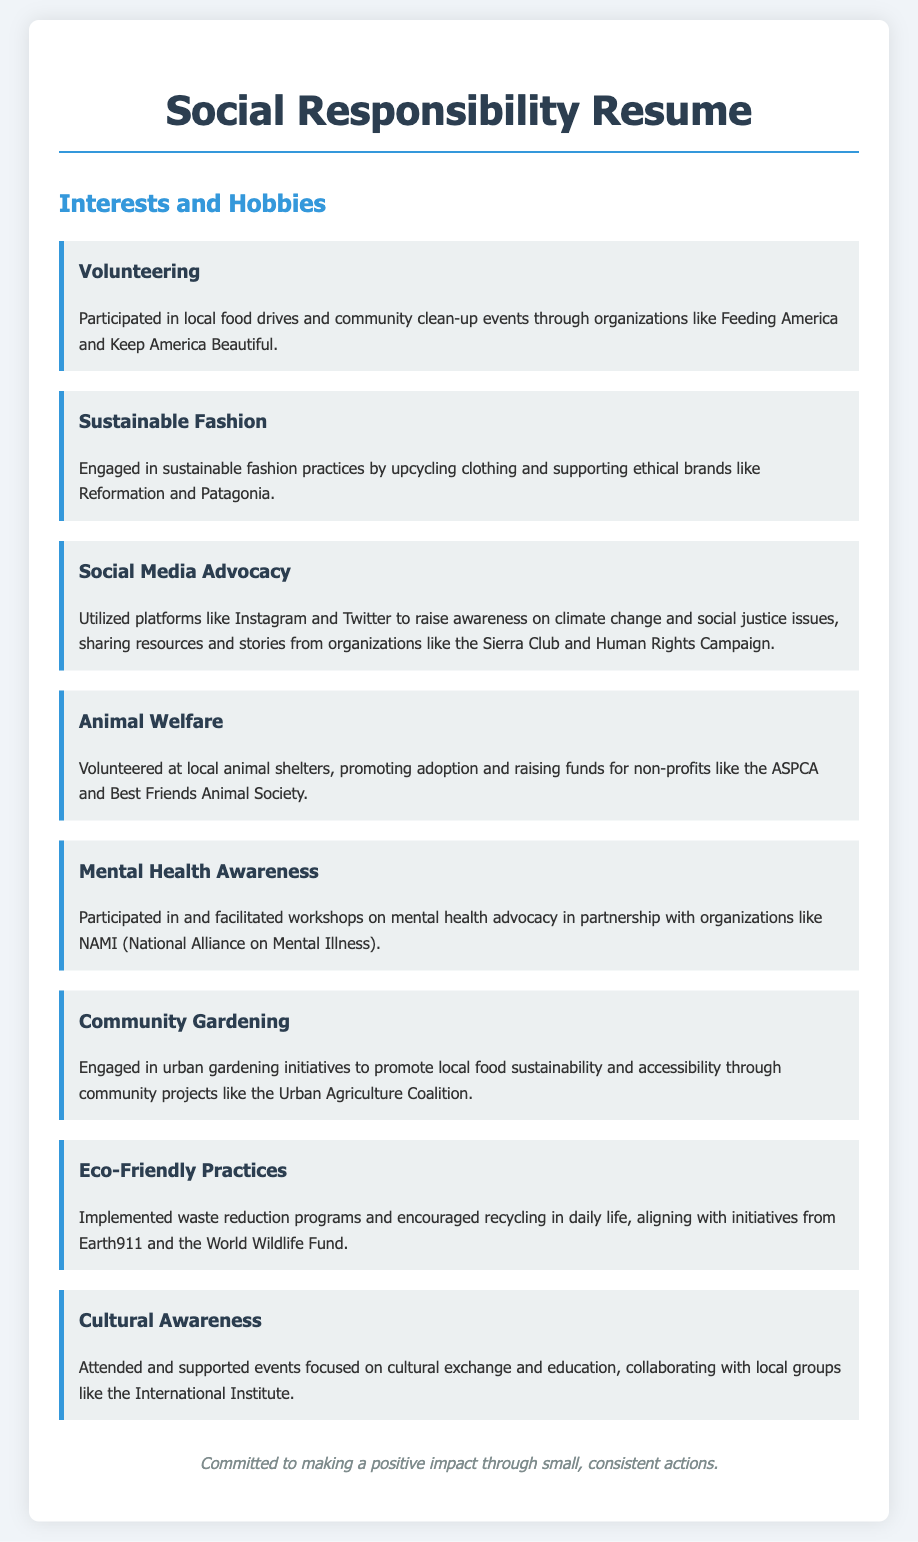What is one of the organizations mentioned for volunteering? The document cites organizations like Feeding America and Keep America Beautiful related to volunteering activities.
Answer: Feeding America What sustainable fashion practice is mentioned? The document describes engagement in sustainable fashion through upcycling clothing.
Answer: Upcycling Which social issues are highlighted in the social media advocacy section? The document mentions raising awareness on climate change and social justice issues through social media platforms.
Answer: Climate change and social justice What is a main focus of the community gardening interest? The document emphasizes promoting local food sustainability and accessibility through urban gardening initiatives.
Answer: Local food sustainability Which organization is associated with mental health awareness activities? The document mentions NAMI (National Alliance on Mental Illness) concerning mental health advocacy workshops.
Answer: NAMI How many main interests and hobbies are listed in the document? The document lists a total of eight main interests and hobbies aligned with social responsibility efforts.
Answer: Eight What type of practices does the eco-friendly section highlight? The document discusses waste reduction programs and encouraging recycling as eco-friendly practices.
Answer: Waste reduction and recycling Which cultural initiative is supported according to the document? The document mentions attending and supporting events focused on cultural exchange and education through local groups.
Answer: Cultural exchange and education 